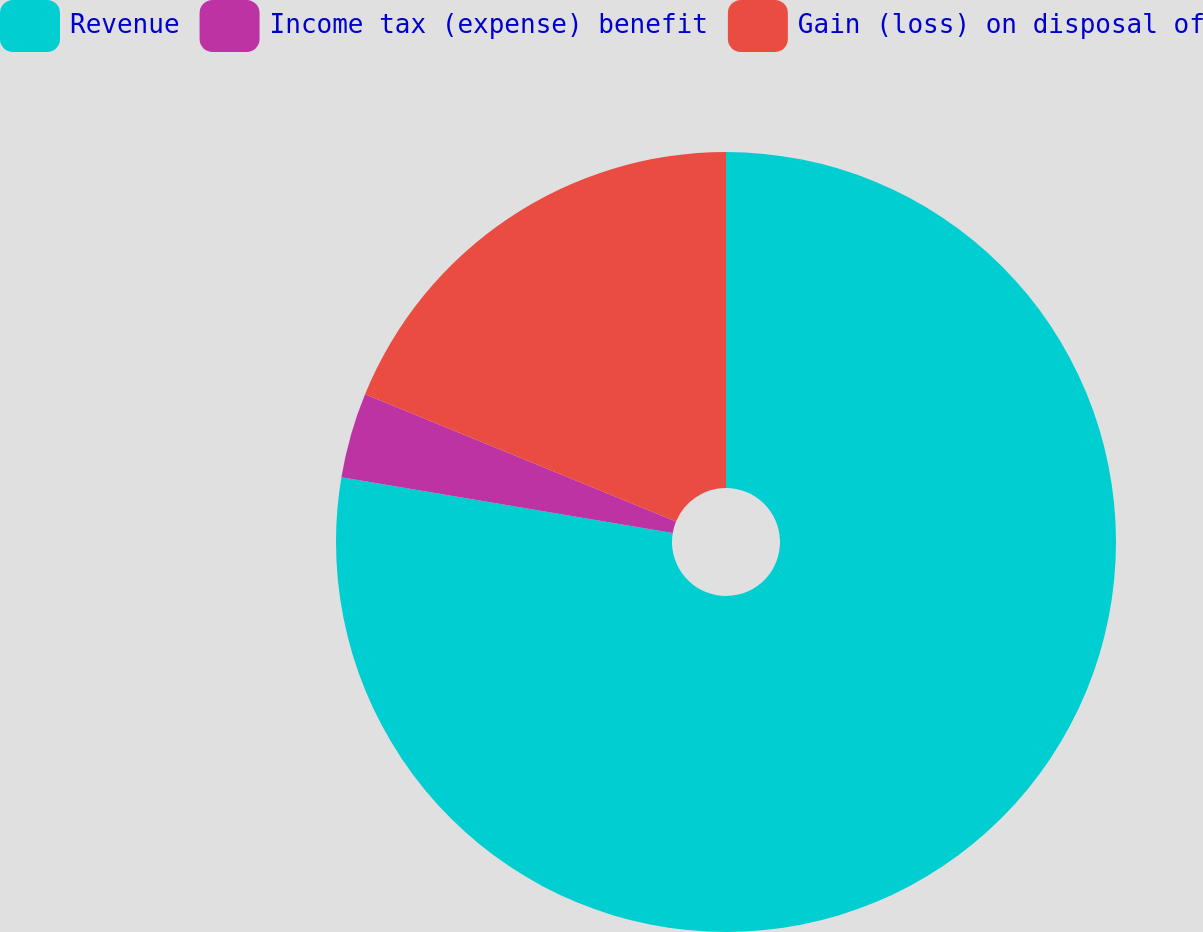Convert chart. <chart><loc_0><loc_0><loc_500><loc_500><pie_chart><fcel>Revenue<fcel>Income tax (expense) benefit<fcel>Gain (loss) on disposal of<nl><fcel>77.65%<fcel>3.53%<fcel>18.82%<nl></chart> 